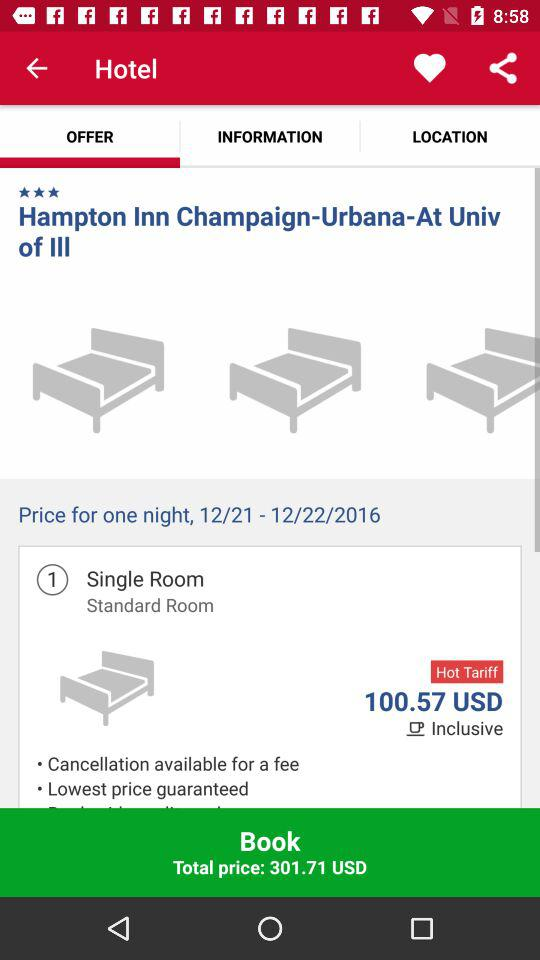What is the price of the Standard Room?
Answer the question using a single word or phrase. 100.57 USD 